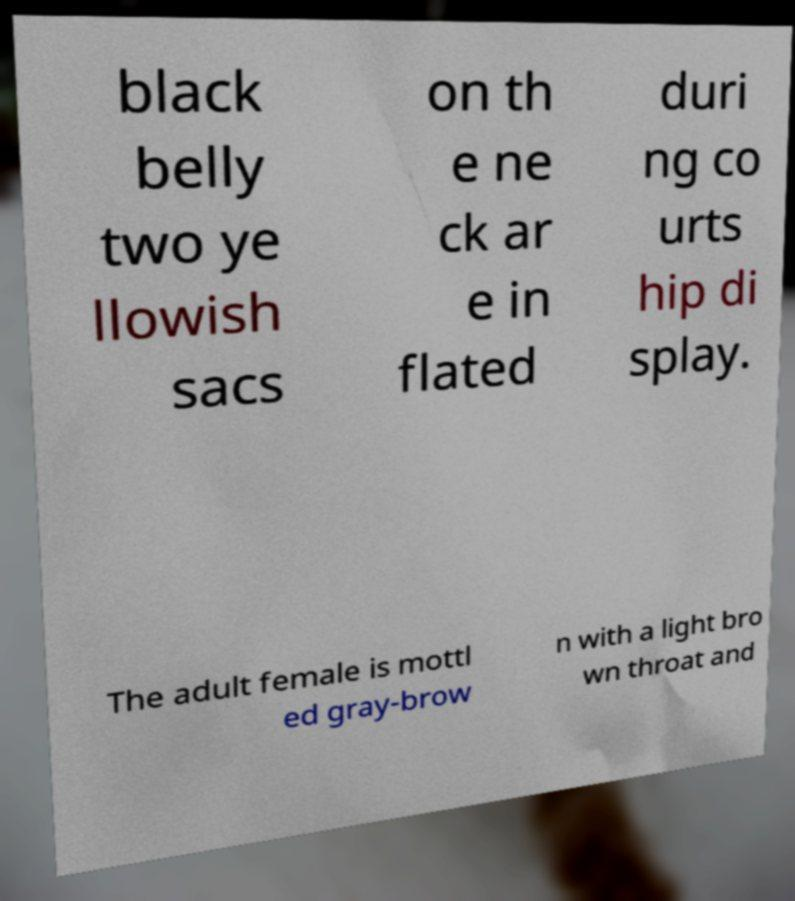Please read and relay the text visible in this image. What does it say? black belly two ye llowish sacs on th e ne ck ar e in flated duri ng co urts hip di splay. The adult female is mottl ed gray-brow n with a light bro wn throat and 